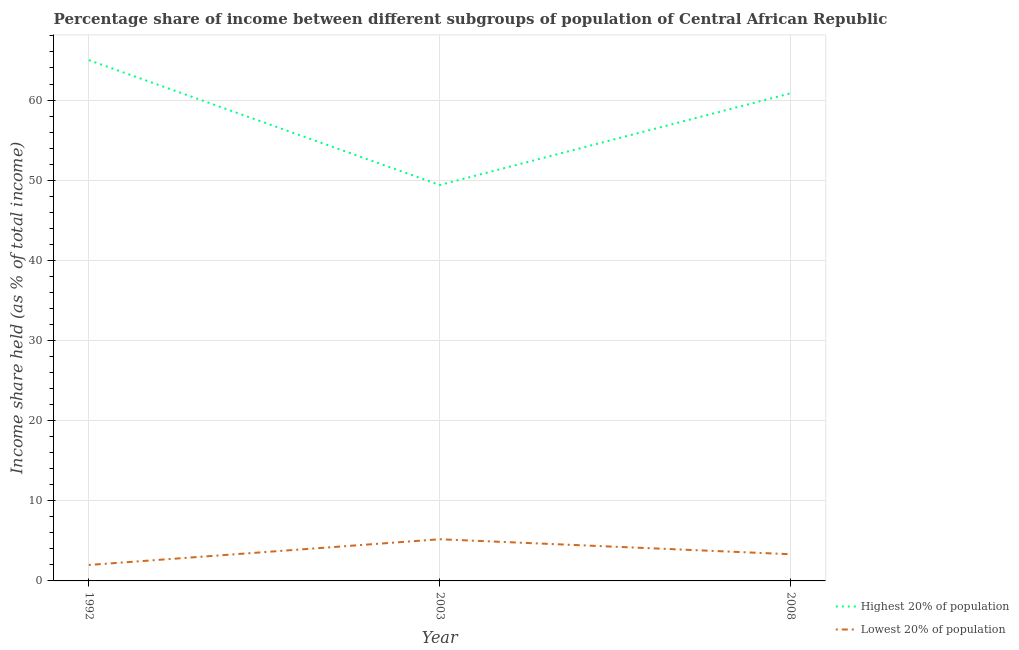How many different coloured lines are there?
Your answer should be very brief. 2. Does the line corresponding to income share held by lowest 20% of the population intersect with the line corresponding to income share held by highest 20% of the population?
Provide a short and direct response. No. Is the number of lines equal to the number of legend labels?
Ensure brevity in your answer.  Yes. What is the income share held by lowest 20% of the population in 2003?
Ensure brevity in your answer.  5.2. Across all years, what is the maximum income share held by lowest 20% of the population?
Your response must be concise. 5.2. Across all years, what is the minimum income share held by lowest 20% of the population?
Provide a short and direct response. 1.99. In which year was the income share held by highest 20% of the population maximum?
Ensure brevity in your answer.  1992. In which year was the income share held by lowest 20% of the population minimum?
Make the answer very short. 1992. What is the total income share held by lowest 20% of the population in the graph?
Your response must be concise. 10.52. What is the difference between the income share held by lowest 20% of the population in 2003 and that in 2008?
Ensure brevity in your answer.  1.87. What is the difference between the income share held by highest 20% of the population in 2003 and the income share held by lowest 20% of the population in 2008?
Your response must be concise. 46.07. What is the average income share held by lowest 20% of the population per year?
Ensure brevity in your answer.  3.51. In the year 1992, what is the difference between the income share held by lowest 20% of the population and income share held by highest 20% of the population?
Offer a terse response. -62.99. What is the ratio of the income share held by lowest 20% of the population in 2003 to that in 2008?
Offer a very short reply. 1.56. What is the difference between the highest and the second highest income share held by lowest 20% of the population?
Give a very brief answer. 1.87. What is the difference between the highest and the lowest income share held by highest 20% of the population?
Provide a succinct answer. 15.58. Does the income share held by lowest 20% of the population monotonically increase over the years?
Offer a very short reply. No. Is the income share held by lowest 20% of the population strictly less than the income share held by highest 20% of the population over the years?
Make the answer very short. Yes. How many years are there in the graph?
Give a very brief answer. 3. Does the graph contain any zero values?
Your answer should be very brief. No. How many legend labels are there?
Keep it short and to the point. 2. What is the title of the graph?
Your response must be concise. Percentage share of income between different subgroups of population of Central African Republic. What is the label or title of the Y-axis?
Provide a short and direct response. Income share held (as % of total income). What is the Income share held (as % of total income) in Highest 20% of population in 1992?
Offer a terse response. 64.98. What is the Income share held (as % of total income) in Lowest 20% of population in 1992?
Your response must be concise. 1.99. What is the Income share held (as % of total income) in Highest 20% of population in 2003?
Provide a succinct answer. 49.4. What is the Income share held (as % of total income) in Lowest 20% of population in 2003?
Give a very brief answer. 5.2. What is the Income share held (as % of total income) in Highest 20% of population in 2008?
Ensure brevity in your answer.  60.85. What is the Income share held (as % of total income) in Lowest 20% of population in 2008?
Offer a very short reply. 3.33. Across all years, what is the maximum Income share held (as % of total income) in Highest 20% of population?
Provide a succinct answer. 64.98. Across all years, what is the maximum Income share held (as % of total income) of Lowest 20% of population?
Keep it short and to the point. 5.2. Across all years, what is the minimum Income share held (as % of total income) of Highest 20% of population?
Provide a short and direct response. 49.4. Across all years, what is the minimum Income share held (as % of total income) in Lowest 20% of population?
Offer a terse response. 1.99. What is the total Income share held (as % of total income) in Highest 20% of population in the graph?
Give a very brief answer. 175.23. What is the total Income share held (as % of total income) of Lowest 20% of population in the graph?
Your response must be concise. 10.52. What is the difference between the Income share held (as % of total income) in Highest 20% of population in 1992 and that in 2003?
Provide a short and direct response. 15.58. What is the difference between the Income share held (as % of total income) in Lowest 20% of population in 1992 and that in 2003?
Your answer should be very brief. -3.21. What is the difference between the Income share held (as % of total income) of Highest 20% of population in 1992 and that in 2008?
Provide a short and direct response. 4.13. What is the difference between the Income share held (as % of total income) in Lowest 20% of population in 1992 and that in 2008?
Give a very brief answer. -1.34. What is the difference between the Income share held (as % of total income) in Highest 20% of population in 2003 and that in 2008?
Ensure brevity in your answer.  -11.45. What is the difference between the Income share held (as % of total income) in Lowest 20% of population in 2003 and that in 2008?
Provide a succinct answer. 1.87. What is the difference between the Income share held (as % of total income) of Highest 20% of population in 1992 and the Income share held (as % of total income) of Lowest 20% of population in 2003?
Offer a terse response. 59.78. What is the difference between the Income share held (as % of total income) of Highest 20% of population in 1992 and the Income share held (as % of total income) of Lowest 20% of population in 2008?
Your answer should be very brief. 61.65. What is the difference between the Income share held (as % of total income) of Highest 20% of population in 2003 and the Income share held (as % of total income) of Lowest 20% of population in 2008?
Your answer should be compact. 46.07. What is the average Income share held (as % of total income) in Highest 20% of population per year?
Make the answer very short. 58.41. What is the average Income share held (as % of total income) in Lowest 20% of population per year?
Give a very brief answer. 3.51. In the year 1992, what is the difference between the Income share held (as % of total income) in Highest 20% of population and Income share held (as % of total income) in Lowest 20% of population?
Give a very brief answer. 62.99. In the year 2003, what is the difference between the Income share held (as % of total income) in Highest 20% of population and Income share held (as % of total income) in Lowest 20% of population?
Give a very brief answer. 44.2. In the year 2008, what is the difference between the Income share held (as % of total income) in Highest 20% of population and Income share held (as % of total income) in Lowest 20% of population?
Offer a very short reply. 57.52. What is the ratio of the Income share held (as % of total income) of Highest 20% of population in 1992 to that in 2003?
Ensure brevity in your answer.  1.32. What is the ratio of the Income share held (as % of total income) of Lowest 20% of population in 1992 to that in 2003?
Keep it short and to the point. 0.38. What is the ratio of the Income share held (as % of total income) of Highest 20% of population in 1992 to that in 2008?
Give a very brief answer. 1.07. What is the ratio of the Income share held (as % of total income) of Lowest 20% of population in 1992 to that in 2008?
Make the answer very short. 0.6. What is the ratio of the Income share held (as % of total income) in Highest 20% of population in 2003 to that in 2008?
Keep it short and to the point. 0.81. What is the ratio of the Income share held (as % of total income) of Lowest 20% of population in 2003 to that in 2008?
Your answer should be compact. 1.56. What is the difference between the highest and the second highest Income share held (as % of total income) in Highest 20% of population?
Provide a succinct answer. 4.13. What is the difference between the highest and the second highest Income share held (as % of total income) in Lowest 20% of population?
Give a very brief answer. 1.87. What is the difference between the highest and the lowest Income share held (as % of total income) of Highest 20% of population?
Make the answer very short. 15.58. What is the difference between the highest and the lowest Income share held (as % of total income) in Lowest 20% of population?
Your response must be concise. 3.21. 